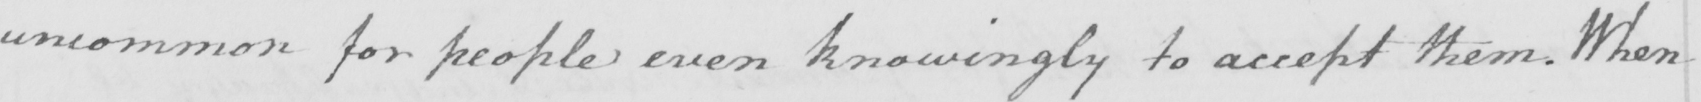What text is written in this handwritten line? uncommon for people even knowingly to accept them . When 